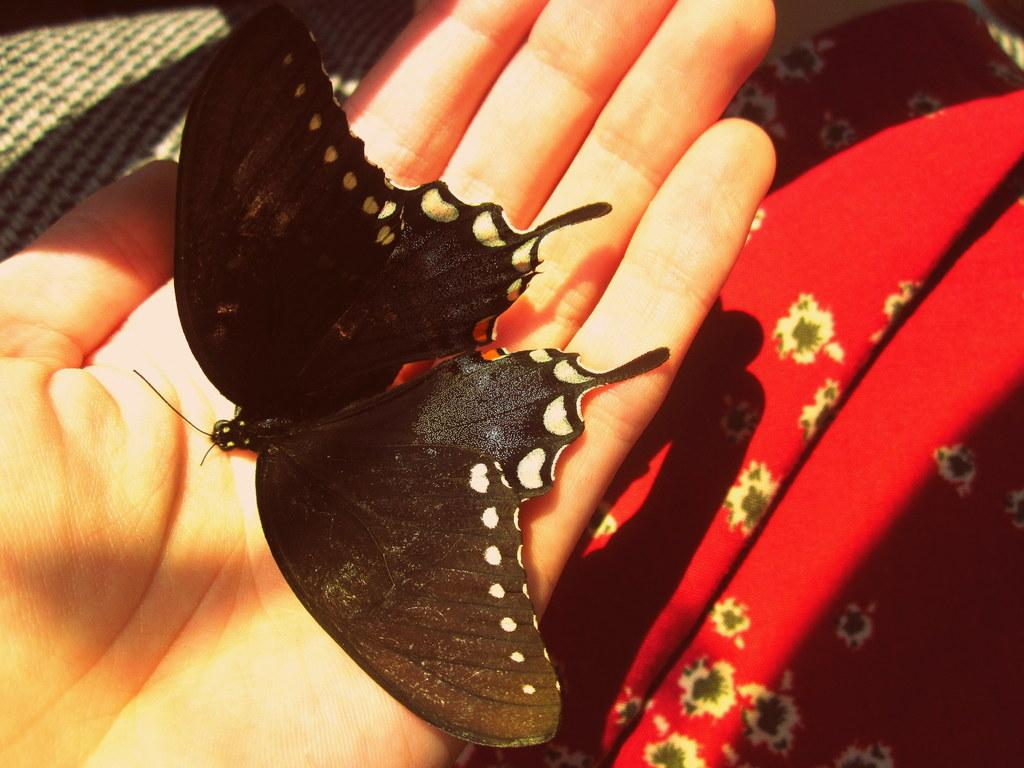What is the main subject of the image? There is a butterfly in the image. Where is the butterfly located? The butterfly is on a person. What color is the butterfly? The butterfly is black in color. What can be seen in the background of the image? There is a red color cloth in the background of the image. What level of difficulty is the butterfly fighting at in the image? There is no indication of a fight or any level of difficulty in the image; it simply shows a black butterfly on a person. 